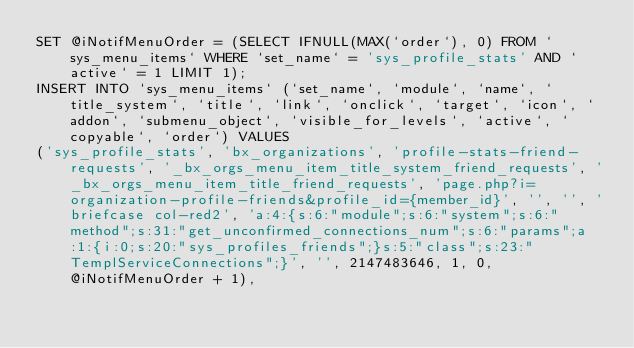<code> <loc_0><loc_0><loc_500><loc_500><_SQL_>SET @iNotifMenuOrder = (SELECT IFNULL(MAX(`order`), 0) FROM `sys_menu_items` WHERE `set_name` = 'sys_profile_stats' AND `active` = 1 LIMIT 1);
INSERT INTO `sys_menu_items` (`set_name`, `module`, `name`, `title_system`, `title`, `link`, `onclick`, `target`, `icon`, `addon`, `submenu_object`, `visible_for_levels`, `active`, `copyable`, `order`) VALUES
('sys_profile_stats', 'bx_organizations', 'profile-stats-friend-requests', '_bx_orgs_menu_item_title_system_friend_requests', '_bx_orgs_menu_item_title_friend_requests', 'page.php?i=organization-profile-friends&profile_id={member_id}', '', '', 'briefcase col-red2', 'a:4:{s:6:"module";s:6:"system";s:6:"method";s:31:"get_unconfirmed_connections_num";s:6:"params";a:1:{i:0;s:20:"sys_profiles_friends";}s:5:"class";s:23:"TemplServiceConnections";}', '', 2147483646, 1, 0, @iNotifMenuOrder + 1),</code> 